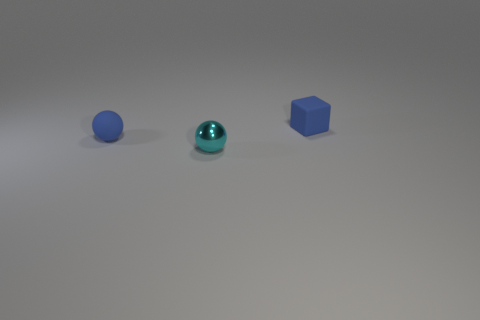What size is the matte ball that is the same color as the block?
Your answer should be very brief. Small. How many other objects are the same size as the blue sphere?
Make the answer very short. 2. The tiny matte object in front of the matte object that is right of the matte thing in front of the small block is what color?
Give a very brief answer. Blue. The object that is behind the small cyan object and to the left of the blue block has what shape?
Offer a terse response. Sphere. How many other things are there of the same shape as the tiny cyan metal thing?
Ensure brevity in your answer.  1. There is a blue thing to the right of the blue thing that is on the left side of the matte object that is right of the cyan metallic ball; what is its shape?
Offer a very short reply. Cube. How many things are either tiny metal spheres or small rubber objects behind the cyan shiny sphere?
Ensure brevity in your answer.  3. There is a tiny matte object on the left side of the cyan object; is its shape the same as the small blue object right of the cyan ball?
Give a very brief answer. No. What number of objects are either shiny blocks or small blue matte cubes?
Your answer should be compact. 1. Is there anything else that is the same material as the small blue block?
Keep it short and to the point. Yes. 